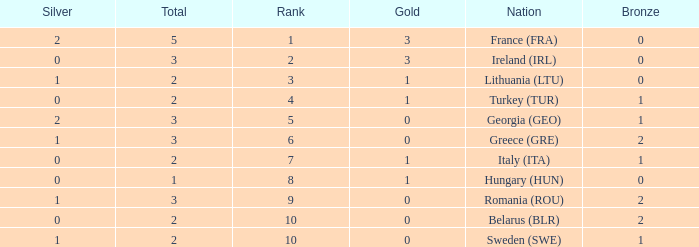What are the most bronze medals in a rank more than 1 with a total larger than 3? None. 